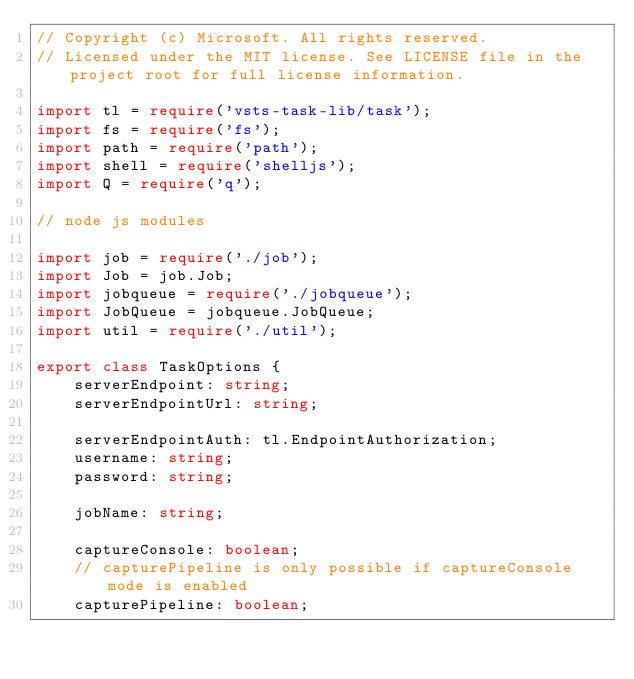<code> <loc_0><loc_0><loc_500><loc_500><_TypeScript_>// Copyright (c) Microsoft. All rights reserved.
// Licensed under the MIT license. See LICENSE file in the project root for full license information.

import tl = require('vsts-task-lib/task');
import fs = require('fs');
import path = require('path');
import shell = require('shelljs');
import Q = require('q');

// node js modules

import job = require('./job');
import Job = job.Job;
import jobqueue = require('./jobqueue');
import JobQueue = jobqueue.JobQueue;
import util = require('./util');

export class TaskOptions {
    serverEndpoint: string;
    serverEndpointUrl: string;

    serverEndpointAuth: tl.EndpointAuthorization;
    username: string;
    password: string;

    jobName: string;

    captureConsole: boolean;
    // capturePipeline is only possible if captureConsole mode is enabled
    capturePipeline: boolean;
</code> 